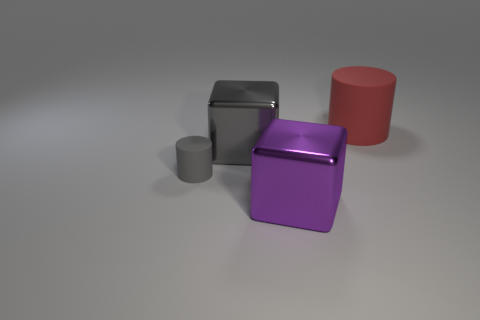Subtract 1 cylinders. How many cylinders are left? 1 Add 2 big gray cubes. How many objects exist? 6 Subtract 0 yellow cubes. How many objects are left? 4 Subtract all gray things. Subtract all tiny purple shiny cylinders. How many objects are left? 2 Add 1 tiny objects. How many tiny objects are left? 2 Add 1 red objects. How many red objects exist? 2 